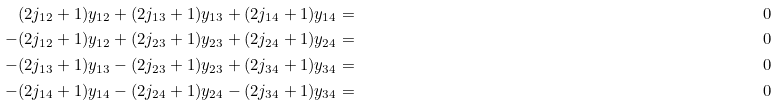<formula> <loc_0><loc_0><loc_500><loc_500>( 2 j _ { 1 2 } + 1 ) y _ { 1 2 } + ( 2 j _ { 1 3 } + 1 ) y _ { 1 3 } + ( 2 j _ { 1 4 } + 1 ) y _ { 1 4 } & = & 0 \\ - ( 2 j _ { 1 2 } + 1 ) y _ { 1 2 } + ( 2 j _ { 2 3 } + 1 ) y _ { 2 3 } + ( 2 j _ { 2 4 } + 1 ) y _ { 2 4 } & = & 0 \\ - ( 2 j _ { 1 3 } + 1 ) y _ { 1 3 } - ( 2 j _ { 2 3 } + 1 ) y _ { 2 3 } + ( 2 j _ { 3 4 } + 1 ) y _ { 3 4 } & = & 0 \\ - ( 2 j _ { 1 4 } + 1 ) y _ { 1 4 } - ( 2 j _ { 2 4 } + 1 ) y _ { 2 4 } - ( 2 j _ { 3 4 } + 1 ) y _ { 3 4 } & = & 0</formula> 